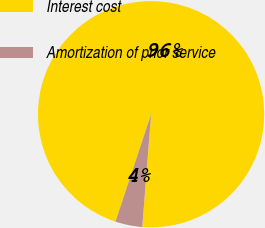Convert chart to OTSL. <chart><loc_0><loc_0><loc_500><loc_500><pie_chart><fcel>Interest cost<fcel>Amortization of prior service<nl><fcel>96.15%<fcel>3.85%<nl></chart> 